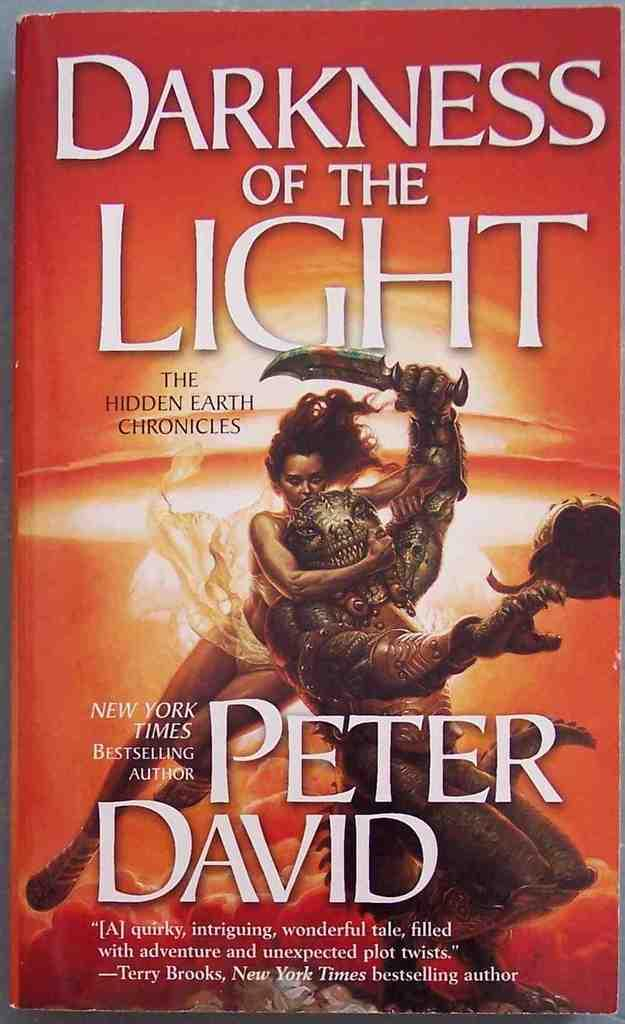<image>
Share a concise interpretation of the image provided. A book written by peter david titled darkness of the light 